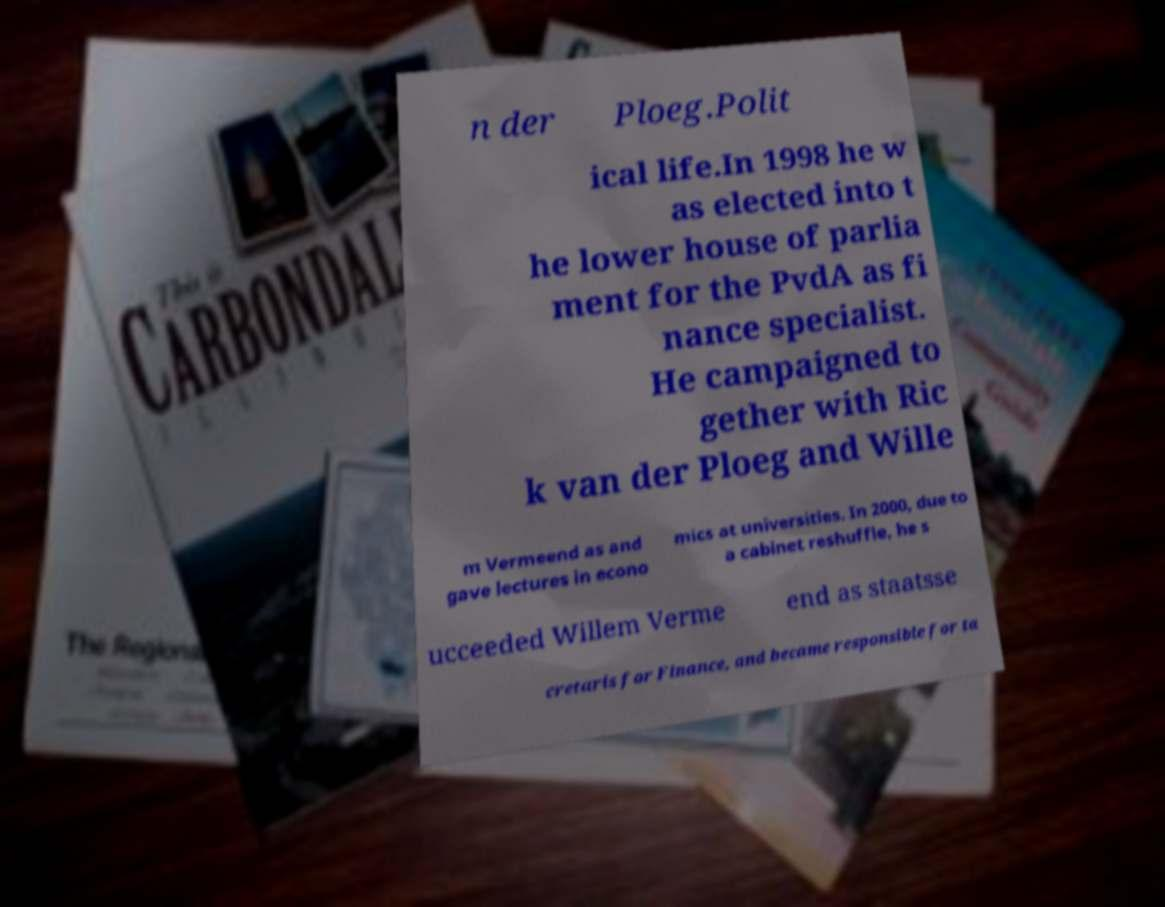Could you extract and type out the text from this image? n der Ploeg.Polit ical life.In 1998 he w as elected into t he lower house of parlia ment for the PvdA as fi nance specialist. He campaigned to gether with Ric k van der Ploeg and Wille m Vermeend as and gave lectures in econo mics at universities. In 2000, due to a cabinet reshuffle, he s ucceeded Willem Verme end as staatsse cretaris for Finance, and became responsible for ta 